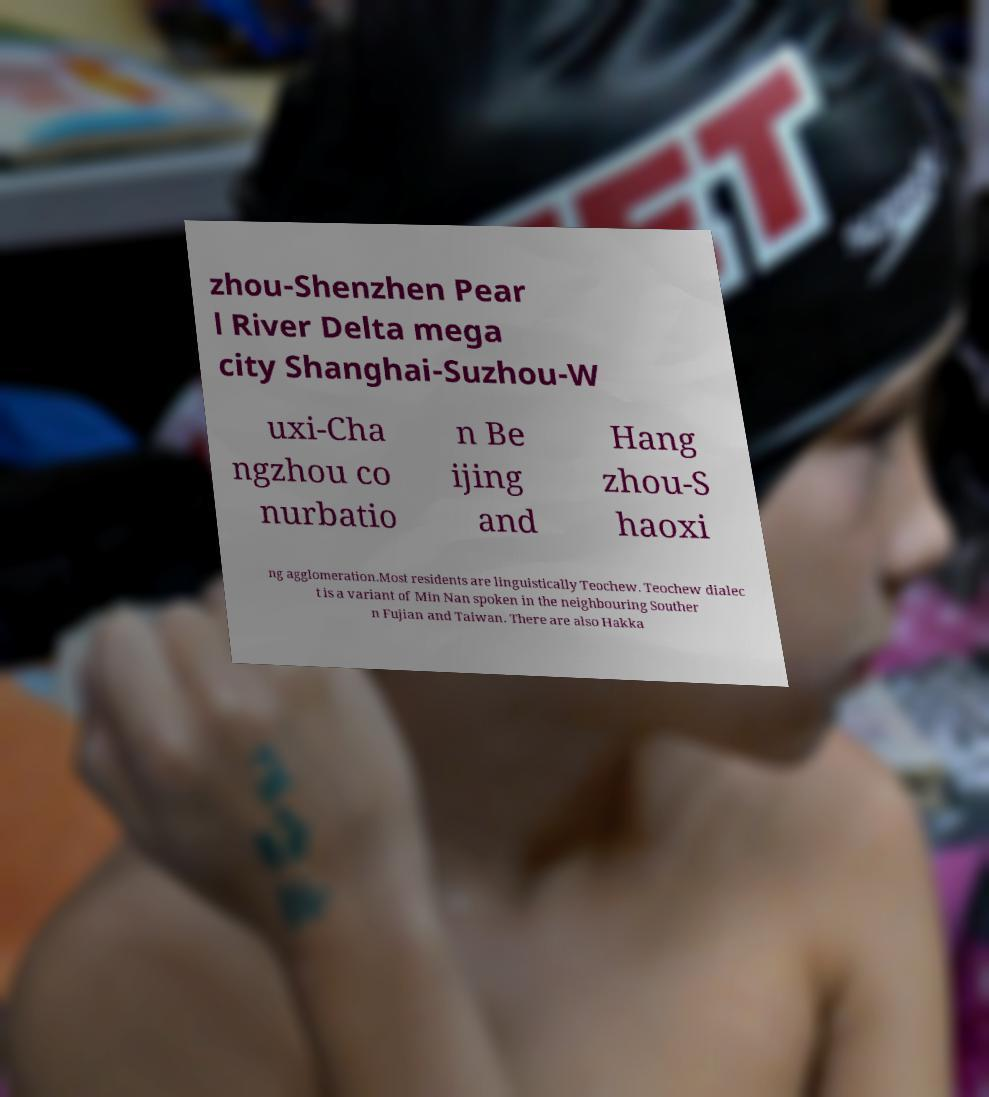Please identify and transcribe the text found in this image. zhou-Shenzhen Pear l River Delta mega city Shanghai-Suzhou-W uxi-Cha ngzhou co nurbatio n Be ijing and Hang zhou-S haoxi ng agglomeration.Most residents are linguistically Teochew. Teochew dialec t is a variant of Min Nan spoken in the neighbouring Souther n Fujian and Taiwan. There are also Hakka 